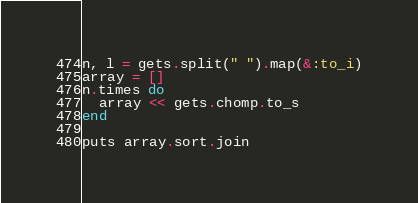<code> <loc_0><loc_0><loc_500><loc_500><_Ruby_>n, l = gets.split(" ").map(&:to_i)
array = []
n.times do
  array << gets.chomp.to_s
end

puts array.sort.join</code> 